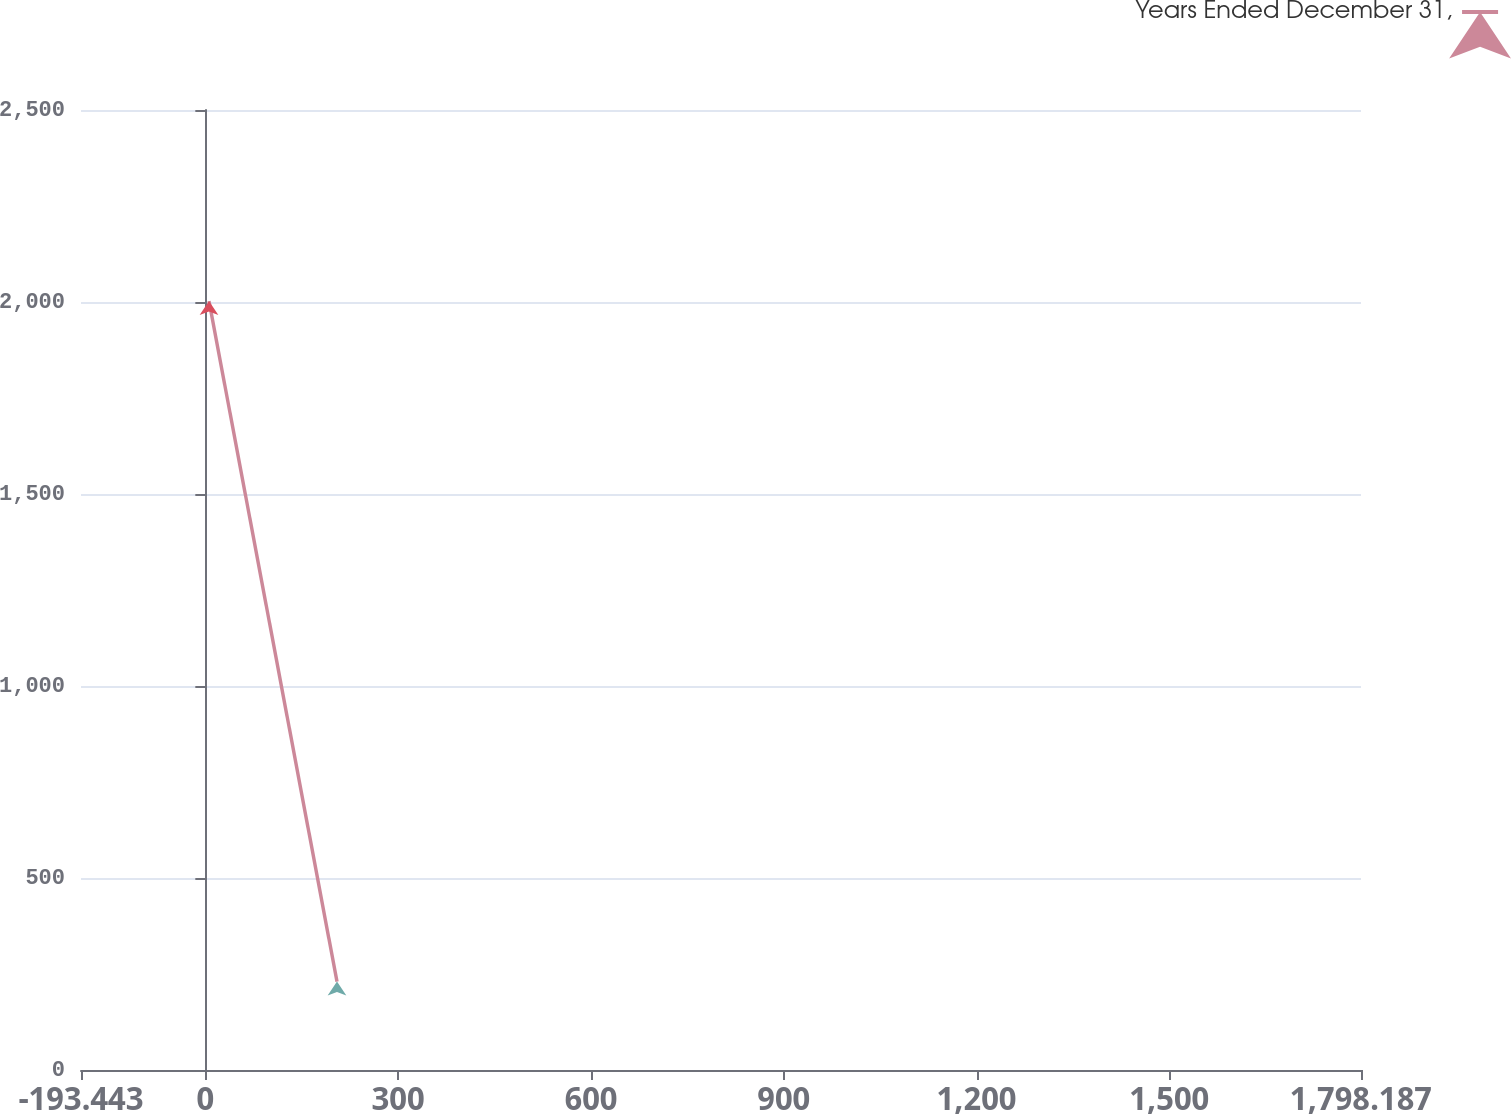<chart> <loc_0><loc_0><loc_500><loc_500><line_chart><ecel><fcel>Years Ended December 31,<nl><fcel>5.72<fcel>2002.36<nl><fcel>204.88<fcel>230.19<nl><fcel>1997.35<fcel>33.28<nl></chart> 